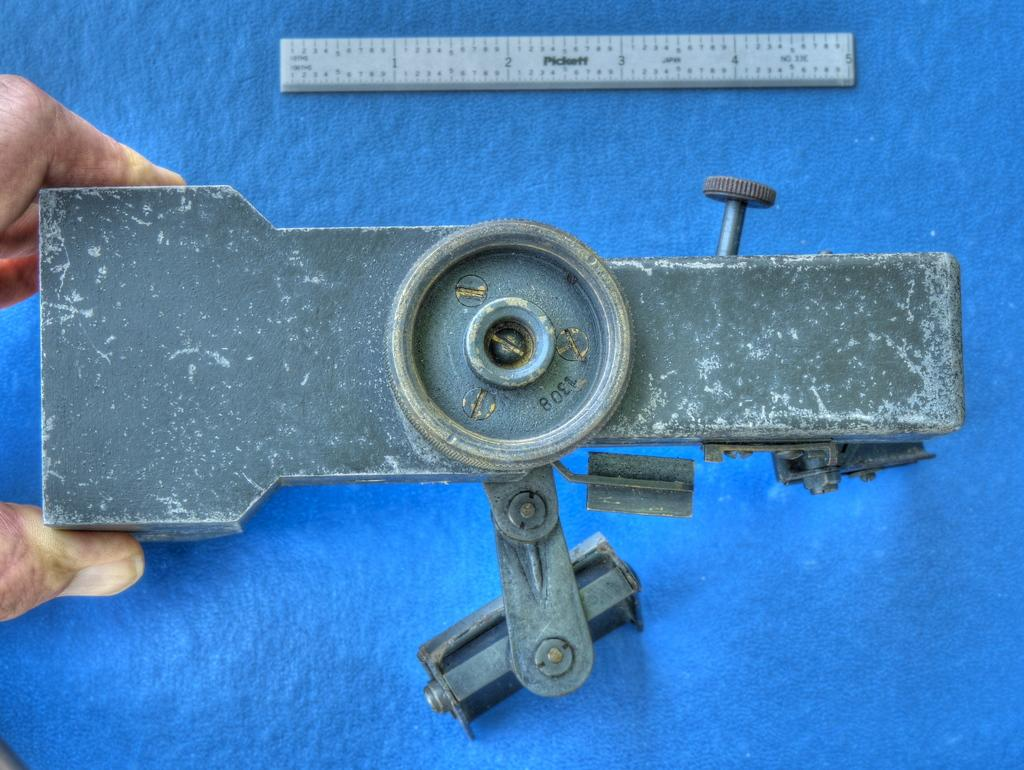<image>
Offer a succinct explanation of the picture presented. A piece of metal machinery with a ruler that goes to 5 inches above it. 